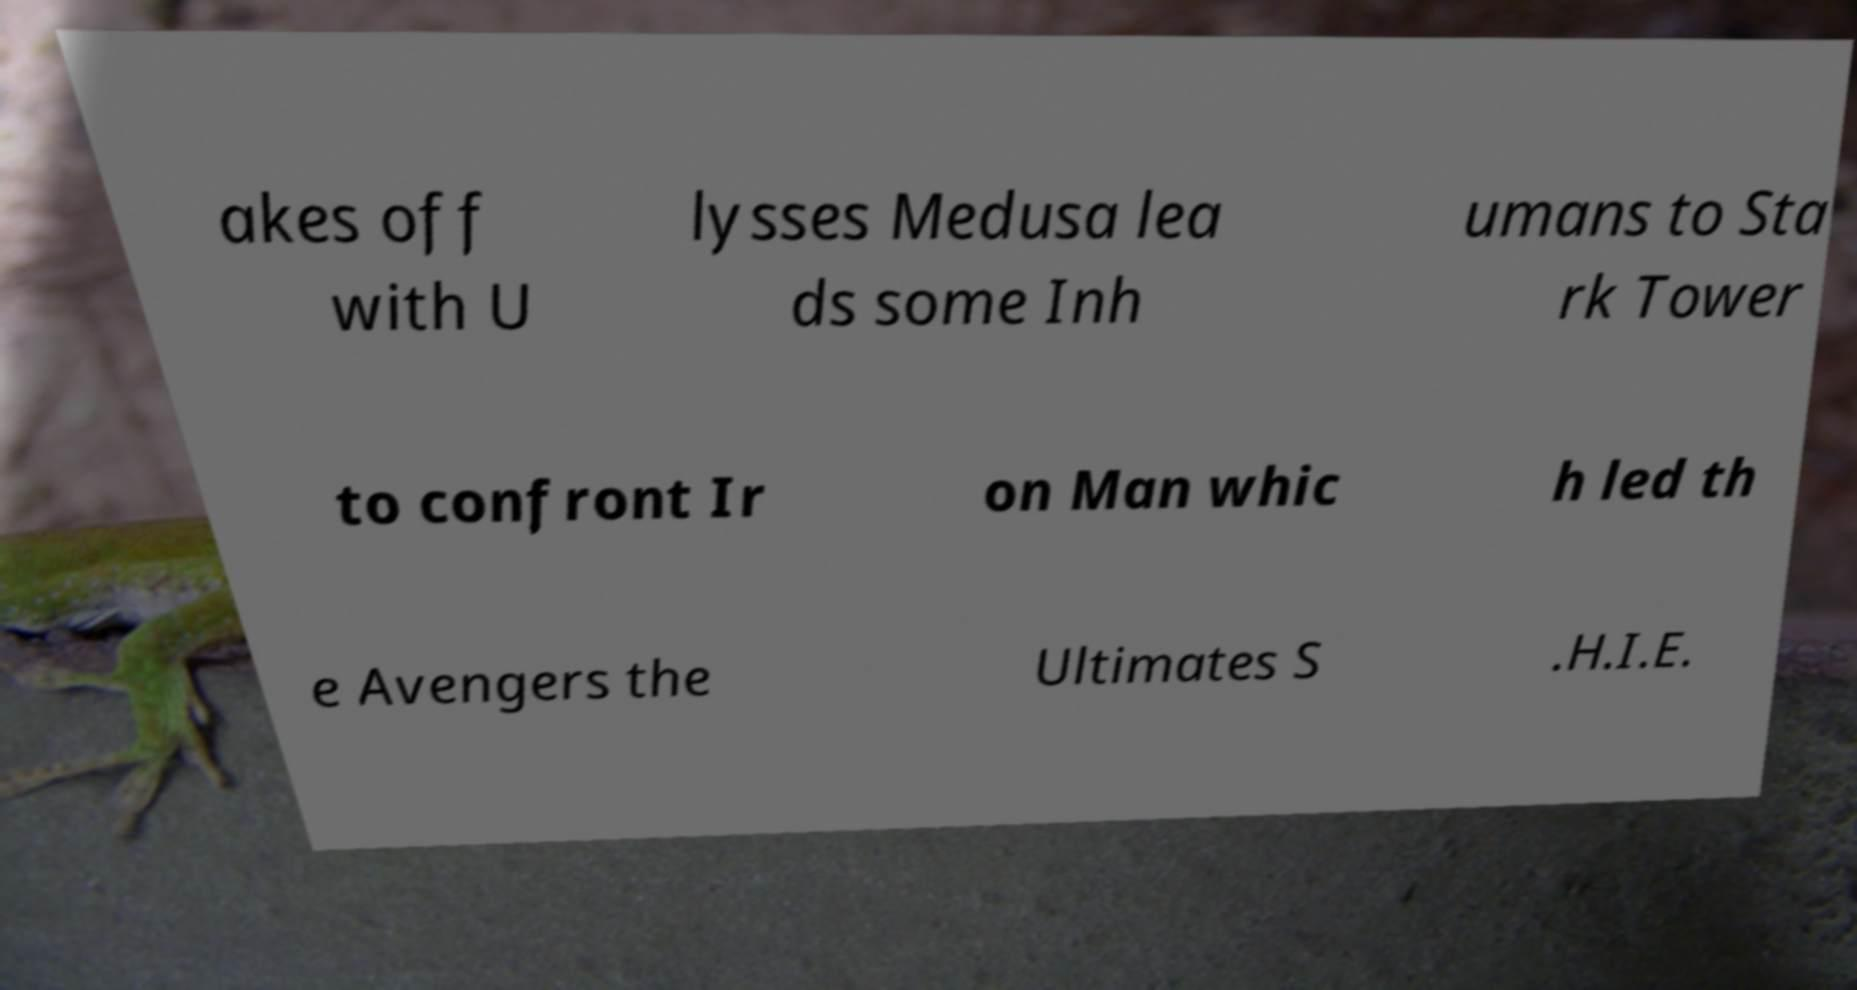Could you assist in decoding the text presented in this image and type it out clearly? akes off with U lysses Medusa lea ds some Inh umans to Sta rk Tower to confront Ir on Man whic h led th e Avengers the Ultimates S .H.I.E. 